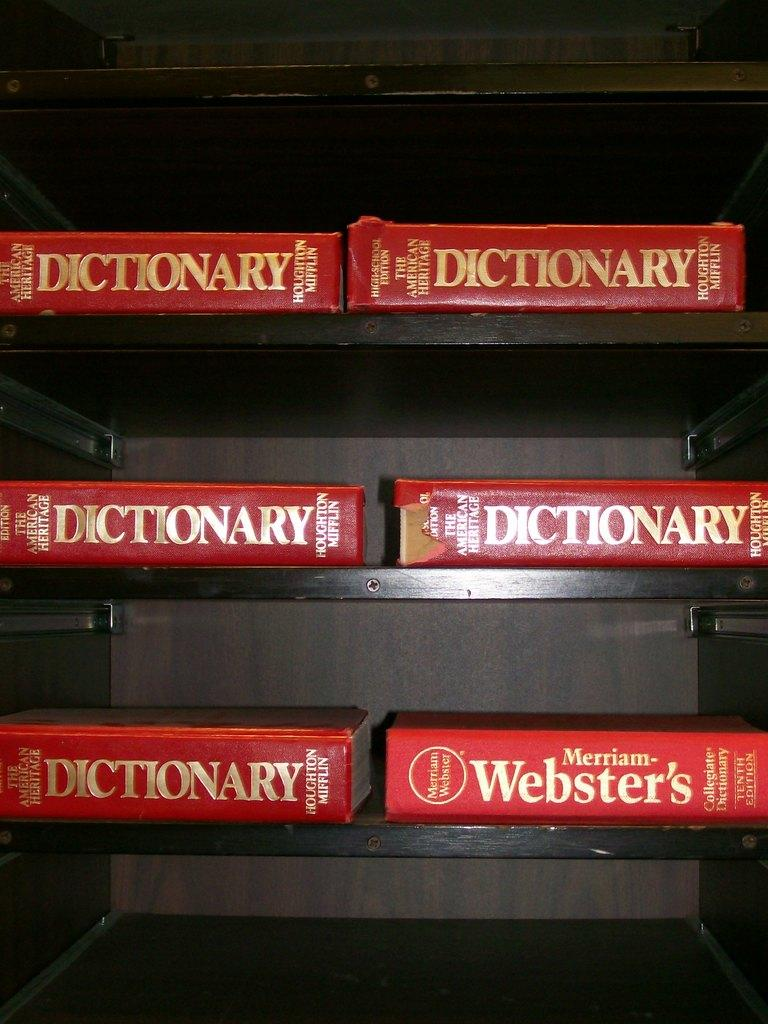<image>
Create a compact narrative representing the image presented. A shelving unit has six dictionaries on it. 